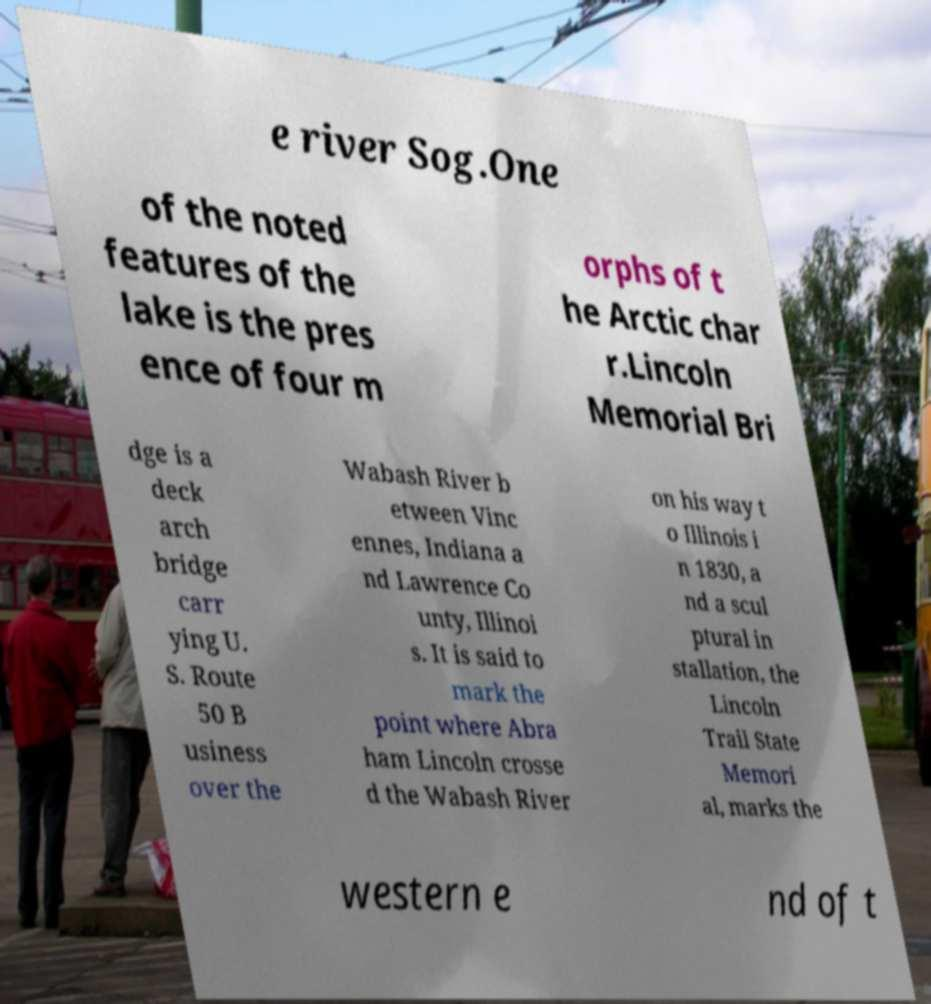Could you assist in decoding the text presented in this image and type it out clearly? e river Sog.One of the noted features of the lake is the pres ence of four m orphs of t he Arctic char r.Lincoln Memorial Bri dge is a deck arch bridge carr ying U. S. Route 50 B usiness over the Wabash River b etween Vinc ennes, Indiana a nd Lawrence Co unty, Illinoi s. It is said to mark the point where Abra ham Lincoln crosse d the Wabash River on his way t o Illinois i n 1830, a nd a scul ptural in stallation, the Lincoln Trail State Memori al, marks the western e nd of t 